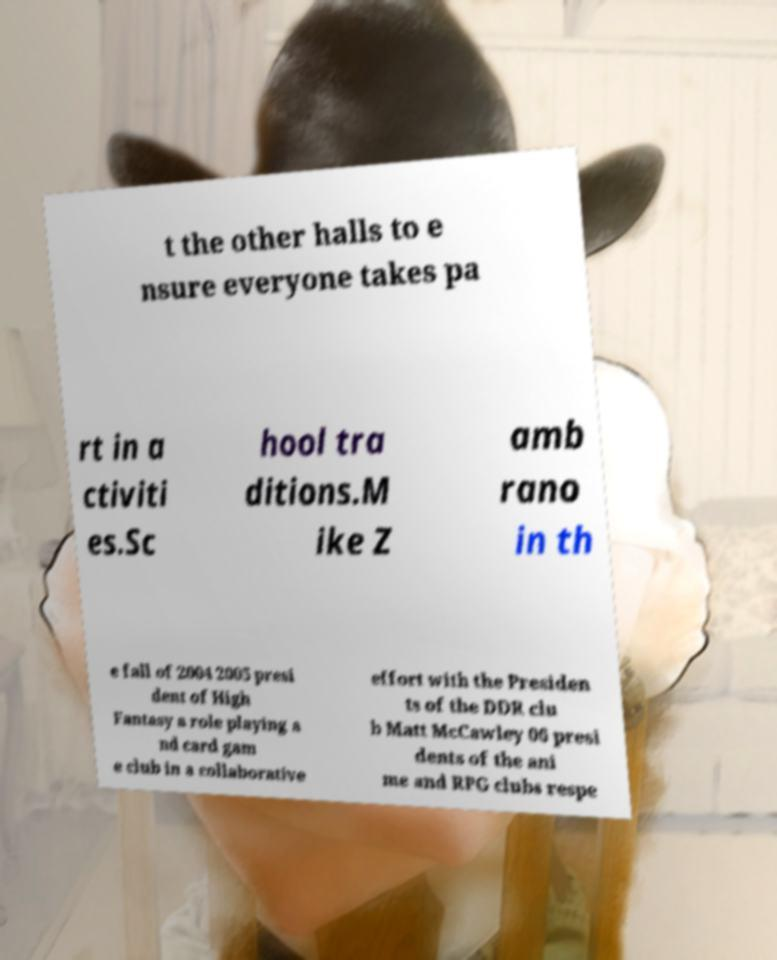For documentation purposes, I need the text within this image transcribed. Could you provide that? t the other halls to e nsure everyone takes pa rt in a ctiviti es.Sc hool tra ditions.M ike Z amb rano in th e fall of 2004 2005 presi dent of High Fantasy a role playing a nd card gam e club in a collaborative effort with the Presiden ts of the DDR clu b Matt McCawley 06 presi dents of the ani me and RPG clubs respe 